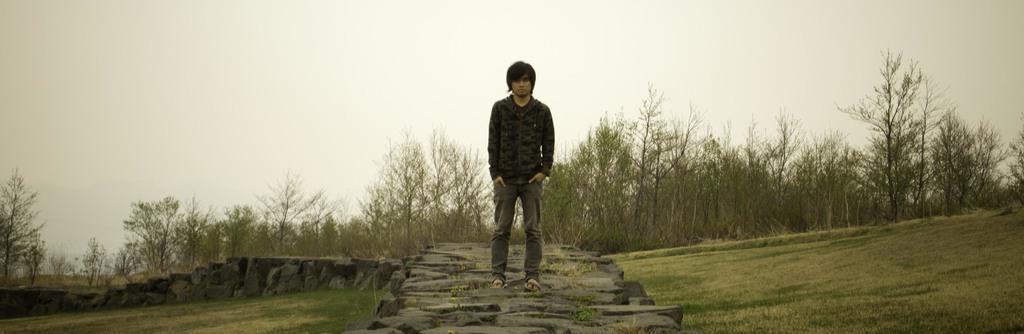Describe this image in one or two sentences. In this picture we can see a boy wearing black color t-shirt and grey pant standing on the rocks and giving a pose in the camera. Behind we can see some trees. 